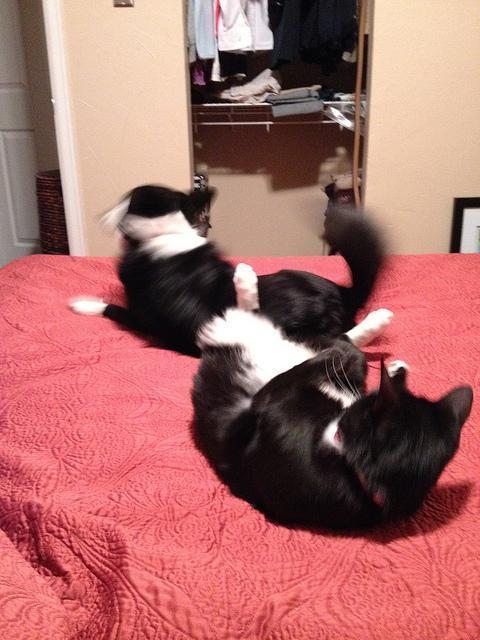How many pets are on the bed?
Give a very brief answer. 2. How many cats are visible?
Give a very brief answer. 2. How many elephants are facing the camera?
Give a very brief answer. 0. 